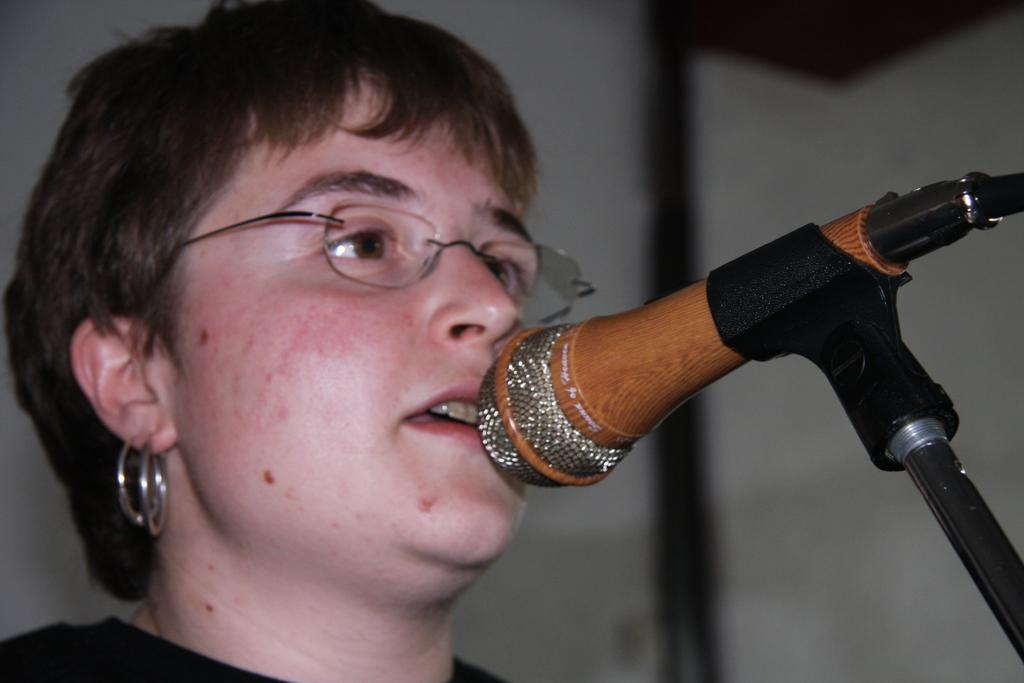Who or what is on the left side of the image? There is a person on the left side of the image. What object is on the right side of the image? There is a microphone (mic) on the right side of the image. Can you describe the background of the image? The background of the image is blurred. Is the person in the image participating in a war? There is no indication of a war or any conflict in the image; it only shows a person and a microphone. Can you see the person kissing someone in the image? There is no kiss or any romantic interaction depicted in the image. 